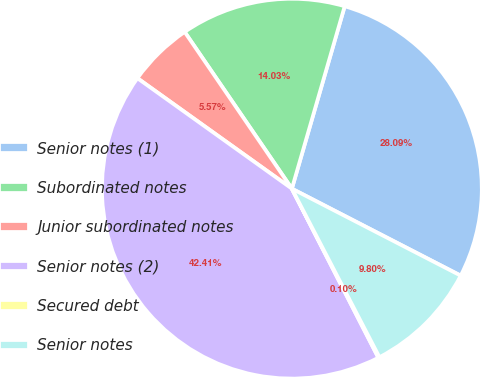Convert chart to OTSL. <chart><loc_0><loc_0><loc_500><loc_500><pie_chart><fcel>Senior notes (1)<fcel>Subordinated notes<fcel>Junior subordinated notes<fcel>Senior notes (2)<fcel>Secured debt<fcel>Senior notes<nl><fcel>28.08%<fcel>14.03%<fcel>5.57%<fcel>42.4%<fcel>0.1%<fcel>9.8%<nl></chart> 